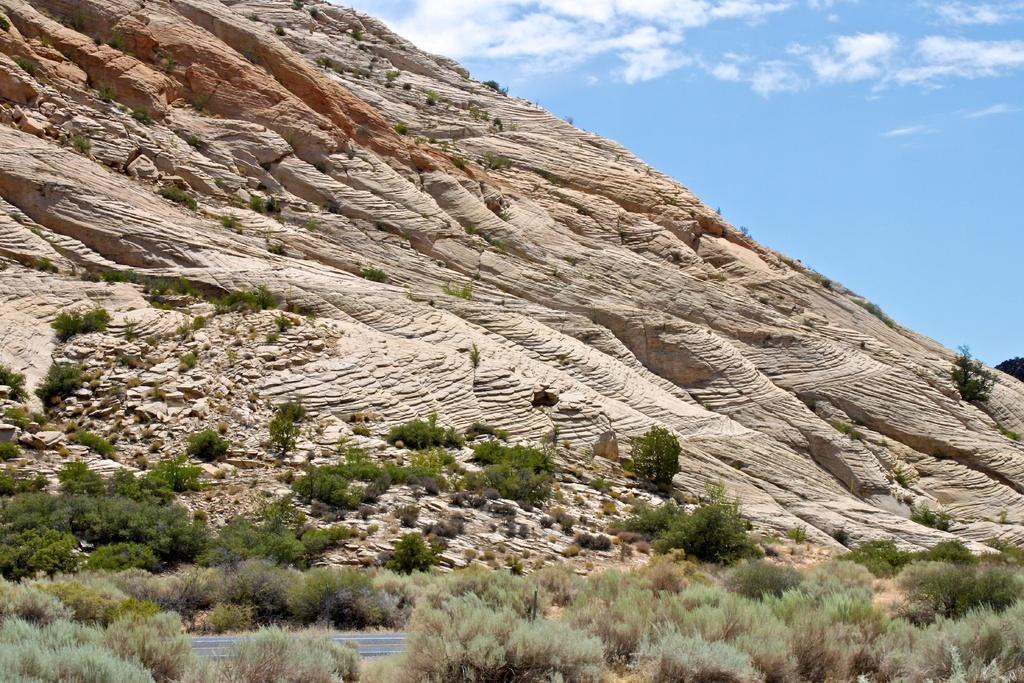Please provide a concise description of this image. In this picture we can see few trees, hill and clouds. 